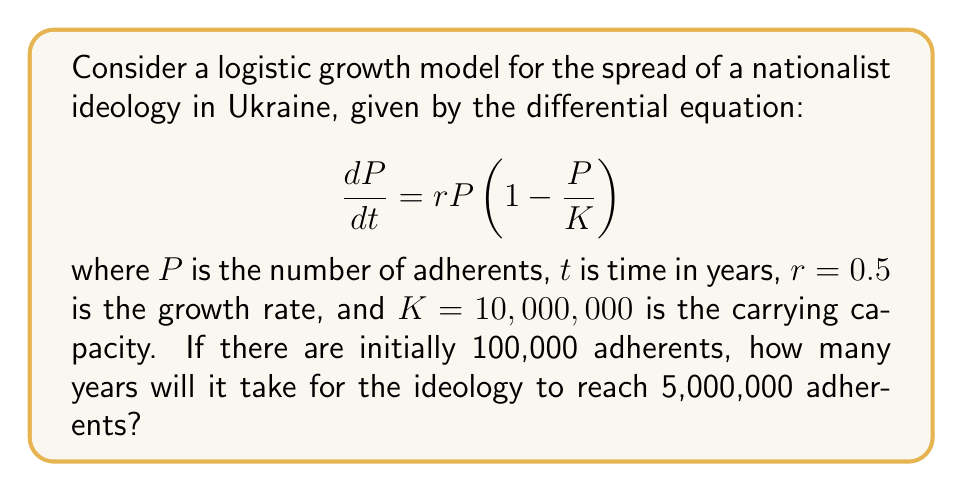Can you solve this math problem? To solve this problem, we need to use the solution to the logistic differential equation:

$$P(t) = \frac{K}{1 + \left(\frac{K}{P_0} - 1\right)e^{-rt}}$$

where $P_0$ is the initial population.

Given:
$K = 10,000,000$
$r = 0.5$
$P_0 = 100,000$
$P(t) = 5,000,000$ (target population)

Let's substitute these values into the equation:

$$5,000,000 = \frac{10,000,000}{1 + \left(\frac{10,000,000}{100,000} - 1\right)e^{-0.5t}}$$

Simplify:

$$0.5 = \frac{1}{1 + 99e^{-0.5t}}$$

Solve for $t$:

$$1 + 99e^{-0.5t} = 2$$
$$99e^{-0.5t} = 1$$
$$e^{-0.5t} = \frac{1}{99}$$
$$-0.5t = \ln\left(\frac{1}{99}\right)$$
$$t = -2\ln\left(\frac{1}{99}\right)$$
$$t = 2\ln(99)$$

Using a calculator:
$$t \approx 9.19 \text{ years}$$
Answer: It will take approximately 9.19 years for the nationalist ideology to reach 5,000,000 adherents in Ukraine. 